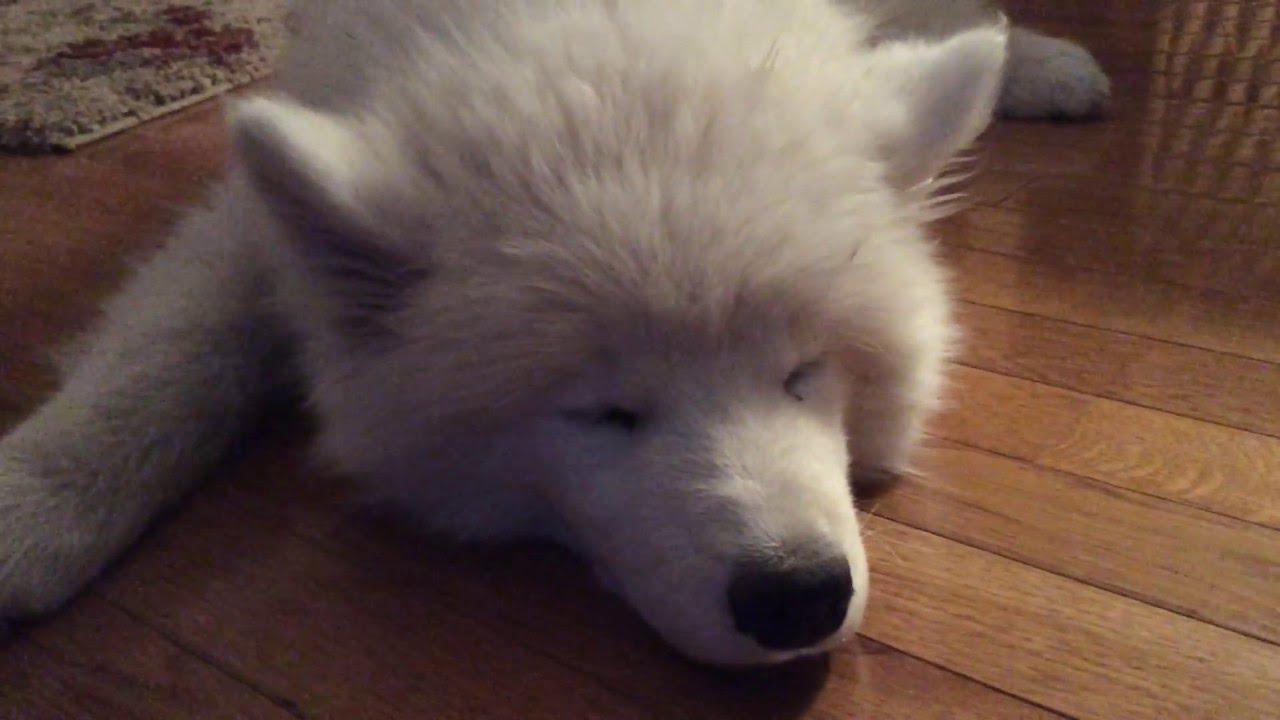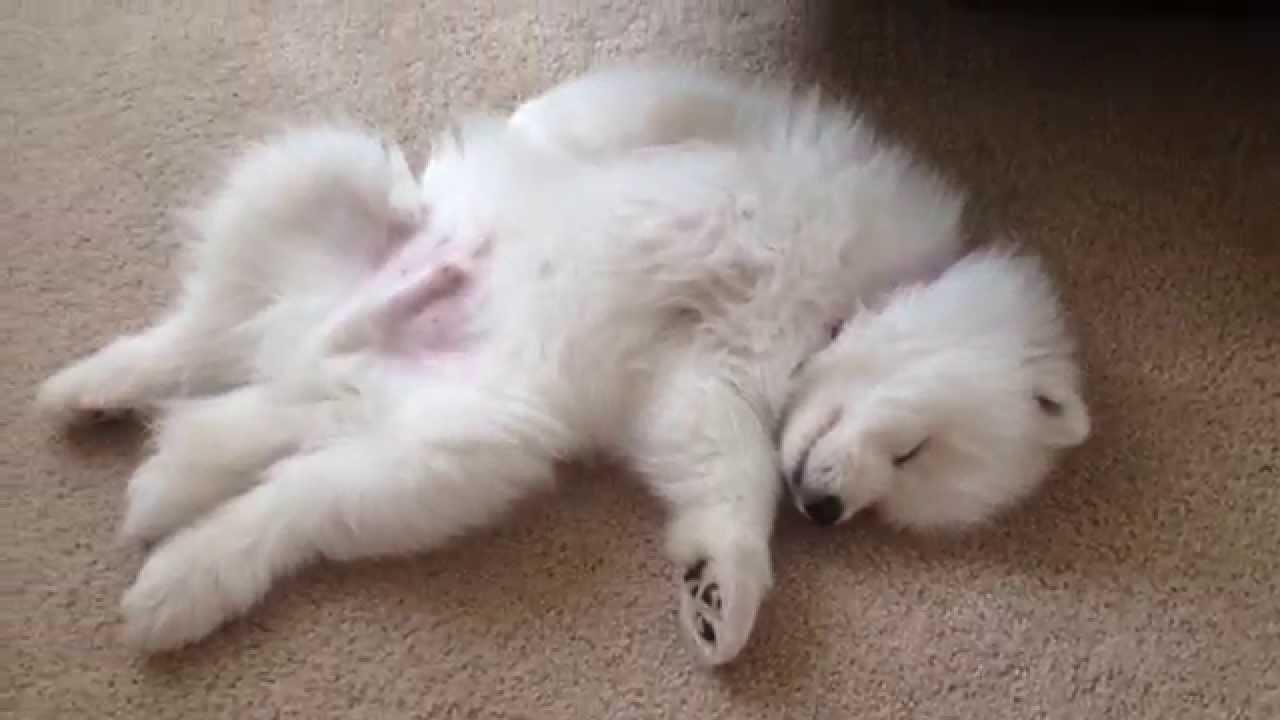The first image is the image on the left, the second image is the image on the right. Assess this claim about the two images: "At least one dog in one of the images has its tongue hanging out.". Correct or not? Answer yes or no. No. The first image is the image on the left, the second image is the image on the right. Assess this claim about the two images: "Right image shows a white dog sleeping on the floor with its belly facing up.". Correct or not? Answer yes or no. Yes. 